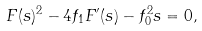<formula> <loc_0><loc_0><loc_500><loc_500>F ( s ) ^ { 2 } - 4 f _ { 1 } F ^ { \prime } ( s ) - f _ { 0 } ^ { 2 } s = 0 ,</formula> 